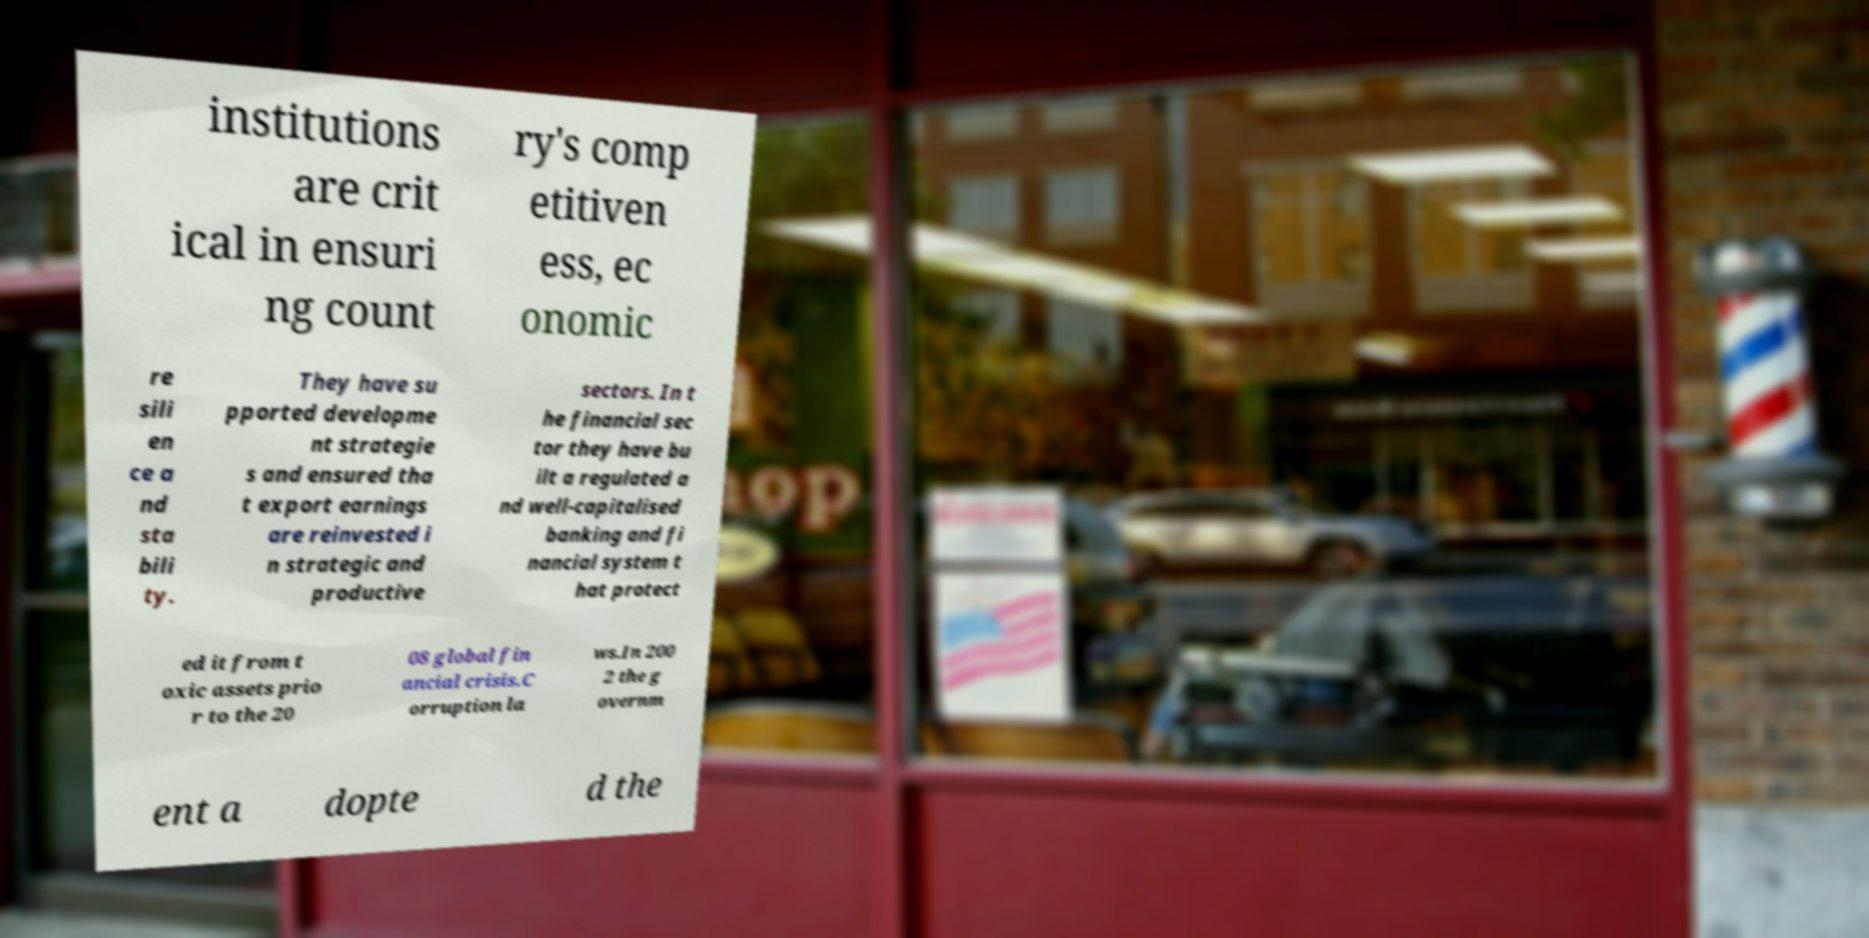Please read and relay the text visible in this image. What does it say? institutions are crit ical in ensuri ng count ry's comp etitiven ess, ec onomic re sili en ce a nd sta bili ty. They have su pported developme nt strategie s and ensured tha t export earnings are reinvested i n strategic and productive sectors. In t he financial sec tor they have bu ilt a regulated a nd well-capitalised banking and fi nancial system t hat protect ed it from t oxic assets prio r to the 20 08 global fin ancial crisis.C orruption la ws.In 200 2 the g overnm ent a dopte d the 